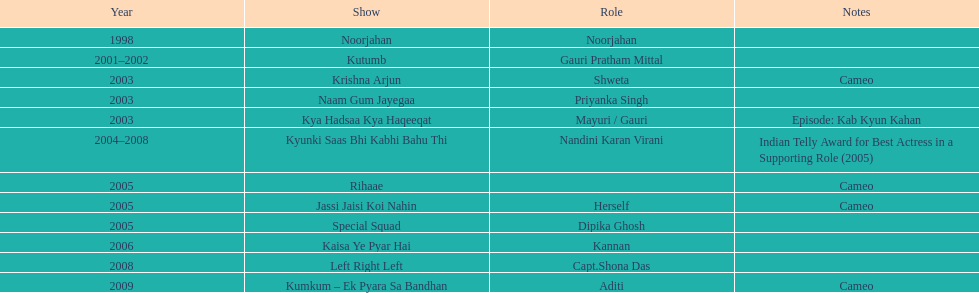Before the turn of the millennium, in how many television shows did gauri tejwani participate? 1. Give me the full table as a dictionary. {'header': ['Year', 'Show', 'Role', 'Notes'], 'rows': [['1998', 'Noorjahan', 'Noorjahan', ''], ['2001–2002', 'Kutumb', 'Gauri Pratham Mittal', ''], ['2003', 'Krishna Arjun', 'Shweta', 'Cameo'], ['2003', 'Naam Gum Jayegaa', 'Priyanka Singh', ''], ['2003', 'Kya Hadsaa Kya Haqeeqat', 'Mayuri / Gauri', 'Episode: Kab Kyun Kahan'], ['2004–2008', 'Kyunki Saas Bhi Kabhi Bahu Thi', 'Nandini Karan Virani', 'Indian Telly Award for Best Actress in a Supporting Role (2005)'], ['2005', 'Rihaae', '', 'Cameo'], ['2005', 'Jassi Jaisi Koi Nahin', 'Herself', 'Cameo'], ['2005', 'Special Squad', 'Dipika Ghosh', ''], ['2006', 'Kaisa Ye Pyar Hai', 'Kannan', ''], ['2008', 'Left Right Left', 'Capt.Shona Das', ''], ['2009', 'Kumkum – Ek Pyara Sa Bandhan', 'Aditi', 'Cameo']]} 